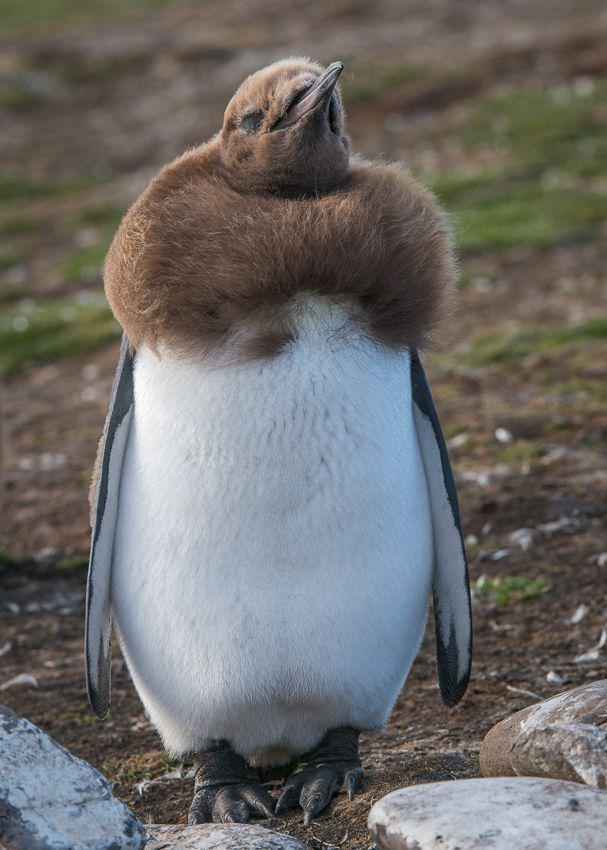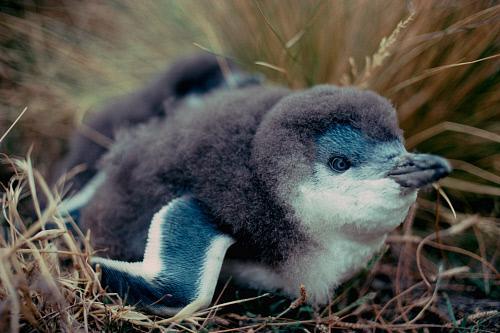The first image is the image on the left, the second image is the image on the right. For the images shown, is this caption "The right image shows a very young fuzzy penguin with some white on its face." true? Answer yes or no. Yes. 